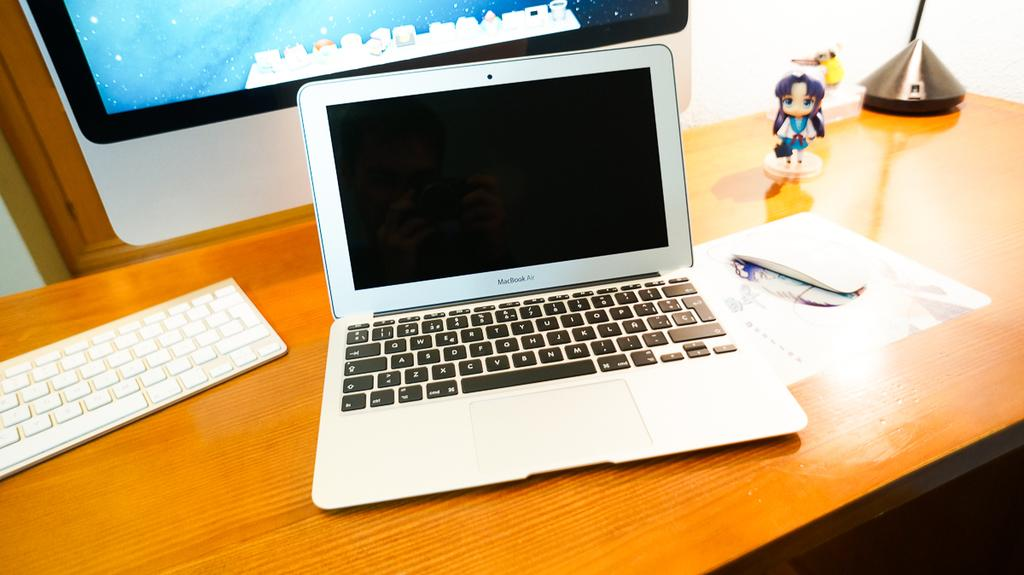What is located in the middle of the image? There is a table in the middle of the image. What electronic device is on the table? A laptop is present on the table. What other items can be seen on the table? There is a keyboard, a paper, and a toy visible on the table. What is visible in the background of the image? There is a screen and a wall in the background of the image. What type of plastic material is used to make the toad in the image? There is no toad present in the image, so it is not possible to determine the type of plastic material used. 